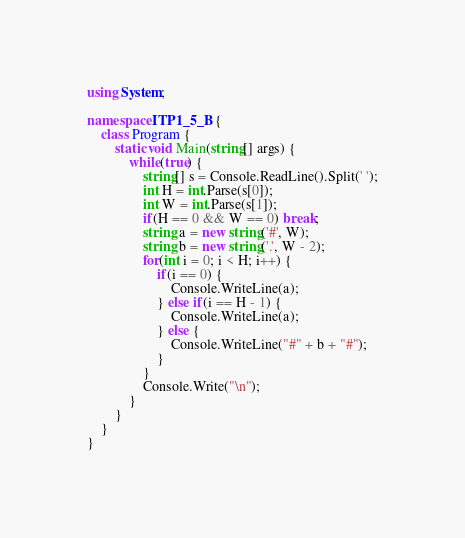Convert code to text. <code><loc_0><loc_0><loc_500><loc_500><_C#_>using System;

namespace ITP1_5_B {
    class Program {
        static void Main(string[] args) {
            while(true) {
                string[] s = Console.ReadLine().Split(' ');
                int H = int.Parse(s[0]);
                int W = int.Parse(s[1]);
                if(H == 0 && W == 0) break;
                string a = new string('#', W);
                string b = new string('.', W - 2);
                for(int i = 0; i < H; i++) {
                    if(i == 0) {
                        Console.WriteLine(a);
                    } else if(i == H - 1) {
                        Console.WriteLine(a);
                    } else {
                        Console.WriteLine("#" + b + "#");
                    }
                }
                Console.Write("\n");
            }
        }
    }
}</code> 